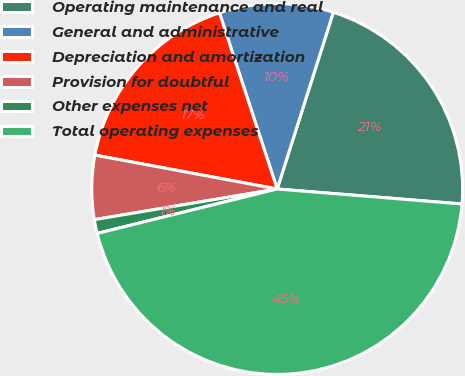<chart> <loc_0><loc_0><loc_500><loc_500><pie_chart><fcel>Operating maintenance and real<fcel>General and administrative<fcel>Depreciation and amortization<fcel>Provision for doubtful<fcel>Other expenses net<fcel>Total operating expenses<nl><fcel>21.39%<fcel>9.94%<fcel>17.03%<fcel>5.57%<fcel>1.21%<fcel>44.86%<nl></chart> 